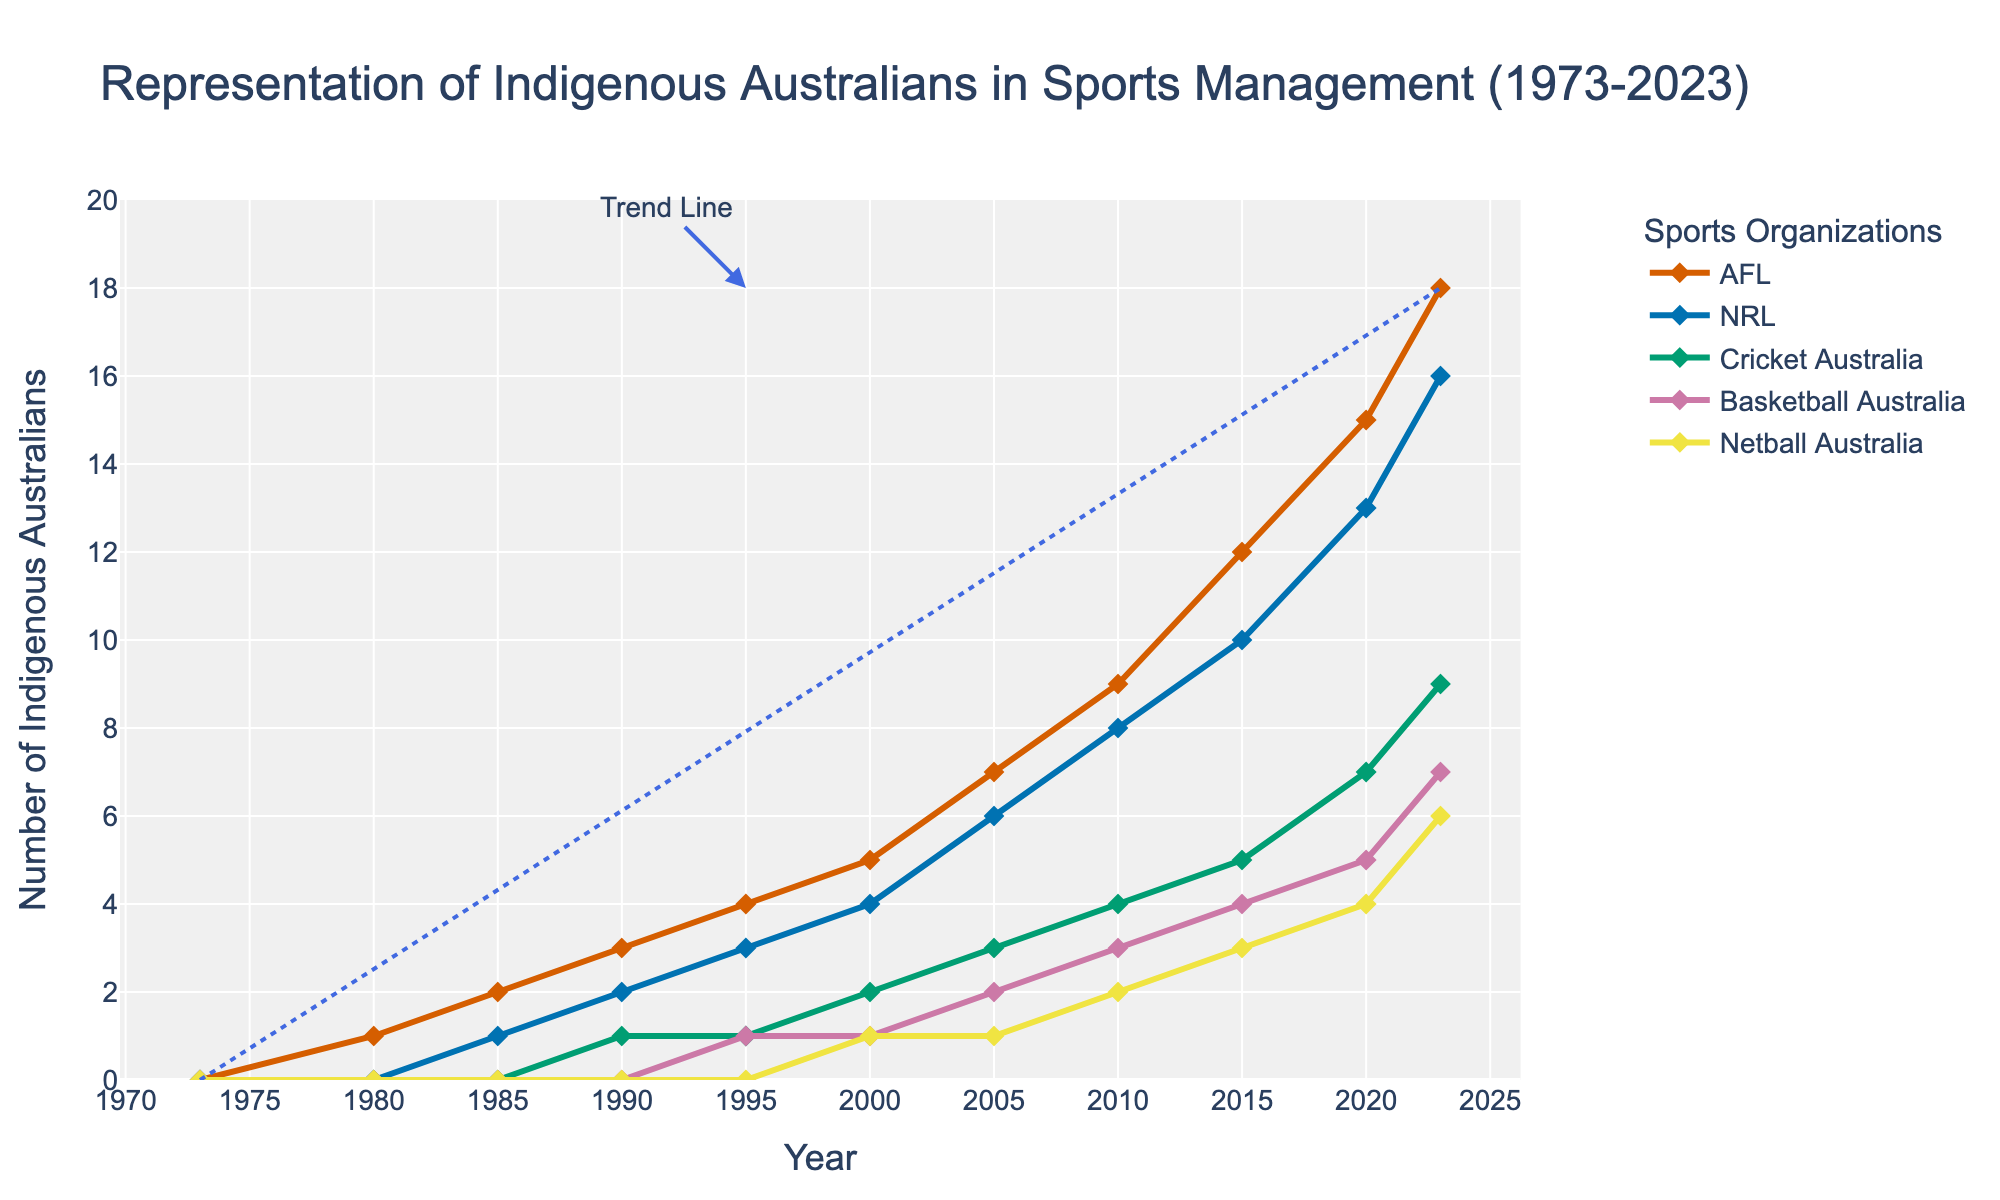what is the overall trend in representation of Indigenous Australians in sports management positions over the past 50 years? The trend line added to the graph shows a steady increase from 0 in 1973 to 18 in 2023. This indicates a positive trend in the representation.
Answer: Steady increase Which sport had the highest number of Indigenous Australians in coaching and management roles in 2023? The 2023 endpoints of the lines represent the current number of Indigenous Australians in each sport. The AFL line ends at 18, the highest number on the graph for that year.
Answer: AFL How did the representation in NRL compare to Basketball Australia in 2010? By looking at the 2010 values, NRL had 8 and Basketball Australia had 3 Indigenous Australians in coaching and management roles.
Answer: NRL had more What is the total number of Indigenous Australians represented in all organizations in 2000? Sum up the individual values for AFL (5), NRL (4), Cricket Australia (2), Basketball Australia (1), and Netball Australia (1). 5 + 4 + 2 + 1 + 1 = 13.
Answer: 13 How much did the representation in Cricket Australia change from 1973 to 2023? In 1973, there were 0 Indigenous Australians in Cricket Australia and by 2023 there were 9. The change is 9 - 0 = 9.
Answer: Increased by 9 Which sport showed the earliest increase in the number of Indigenous Australians? AFL started showing representation in 1980, earlier than any other sport on the graph.
Answer: AFL By how much did the representation in Netball Australia increase from 2010 to 2023? In 2010, Netball Australia had 2 Indigenous Australians. By 2023, it had 6. The increase is 6 - 2 = 4.
Answer: Increased by 4 How does the slope of the trend line compare to the increases in individual sports? The trend line shows a steady linear increase, indicating consistent growth across all sports. Individual sports such as AFL and NRL also show steady increases, matching the overall trend.
Answer: Consistent Which two sports had the closest number of Indigenous Australians in 2020? In 2020, there were 15 in AFL and 13 in NRL. These numbers are the closest compared to other pairs.
Answer: AFL and NRL What notable change happened between 1995 and 2000 across all sports? Each sport shows a positive increase in representation over these years, contributing to a general upward trend. Sum changes: AFL (5-4), NRL (4-3), Cricket Australia (2-1), Basketball Australia (1-1), Netball Australia (1-0), totaling increased representation from 9 to 13.
Answer: General upward trend 